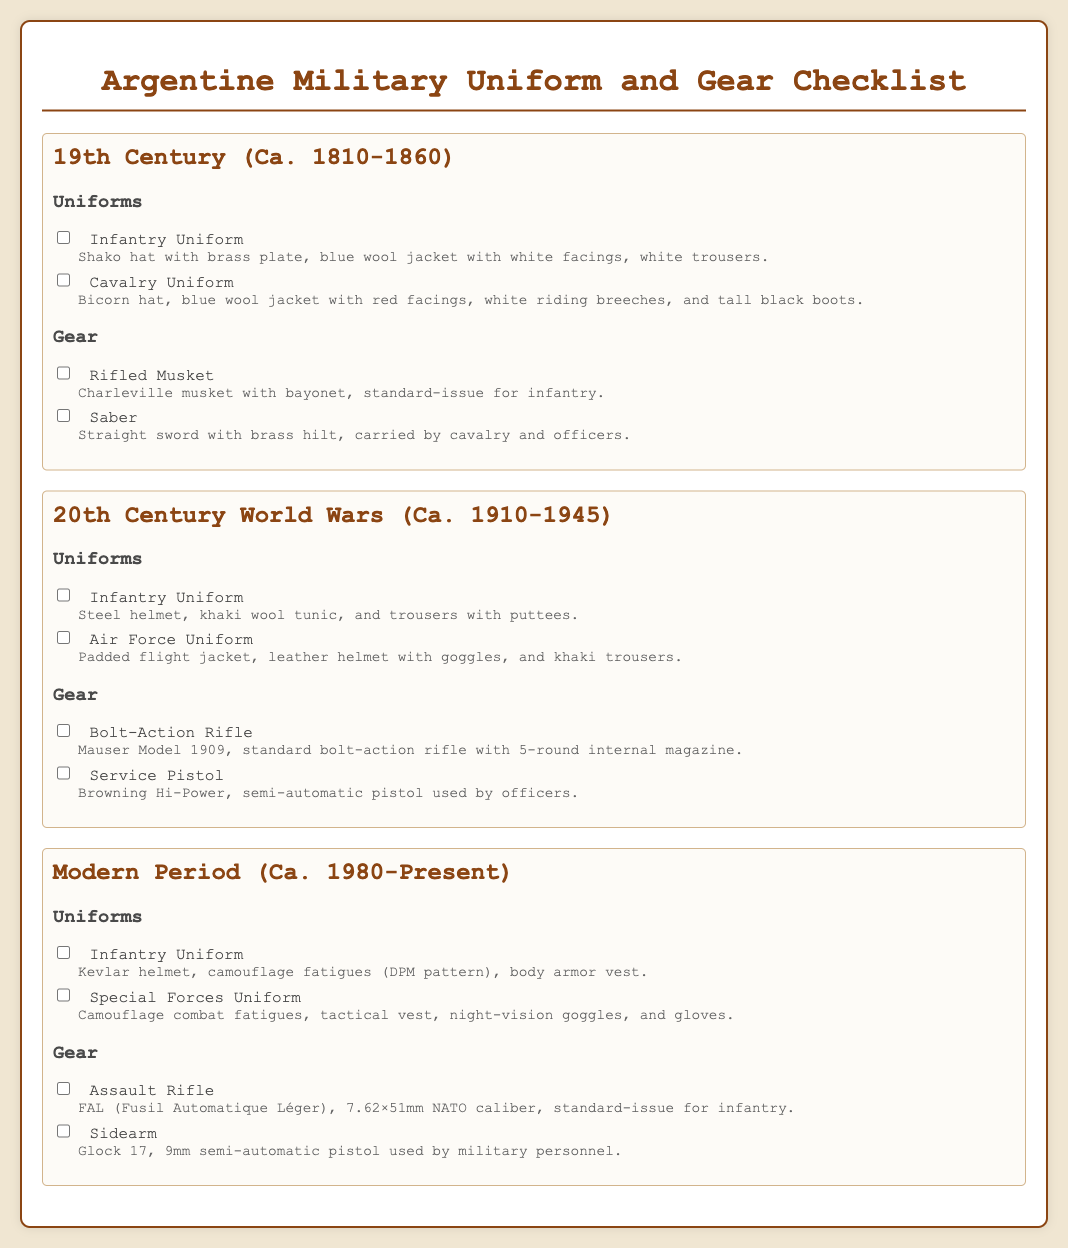What uniform did the Argentine infantry wear in the 19th century? The document describes the 19th-century infantry uniform as consisting of a shako hat, blue wool jacket with white facings, and white trousers.
Answer: Infantry Uniform What type of headgear was used by the cavalry in the 19th century? According to the checklist, the cavalry uniform included a bicorn hat.
Answer: Bicorn hat Which rifle was standard-issue for infantry in the 20th century? The checklist states that the standard bolt-action rifle for infantry was the Mauser Model 1909.
Answer: Mauser Model 1909 What is the ammunition caliber of the standard-issue assault rifle in the modern period? The document details that the standard-issue FAL assault rifle uses 7.62×51mm NATO caliber ammunition.
Answer: 7.62×51mm NATO How many uniforms are listed for the modern period? The document lists two uniforms under the modern period: Infantry Uniform and Special Forces Uniform.
Answer: 2 